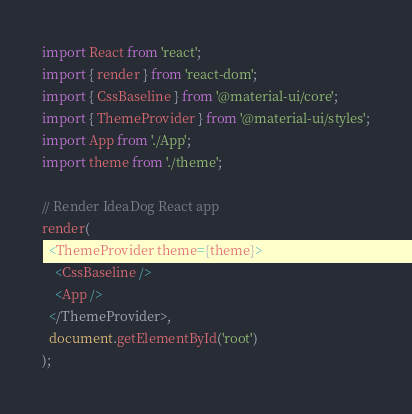Convert code to text. <code><loc_0><loc_0><loc_500><loc_500><_TypeScript_>import React from 'react';
import { render } from 'react-dom';
import { CssBaseline } from '@material-ui/core';
import { ThemeProvider } from '@material-ui/styles';
import App from './App';
import theme from './theme';

// Render IdeaDog React app
render(
  <ThemeProvider theme={theme}>
    <CssBaseline />
    <App />
  </ThemeProvider>,
  document.getElementById('root')
);
</code> 